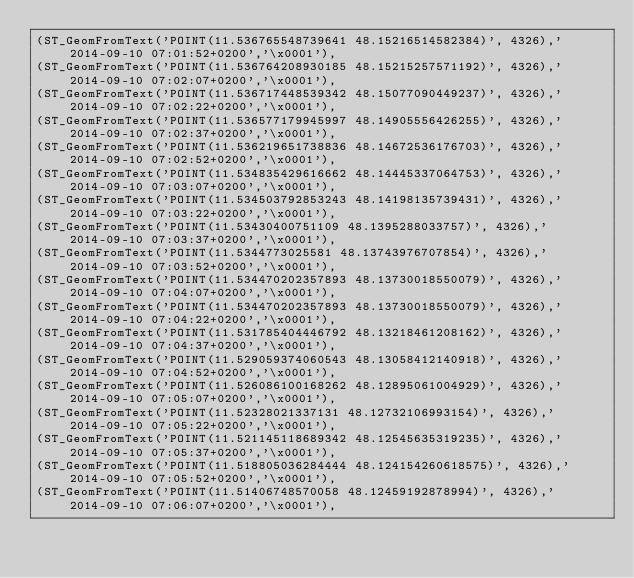<code> <loc_0><loc_0><loc_500><loc_500><_SQL_>(ST_GeomFromText('POINT(11.536765548739641 48.15216514582384)', 4326),'2014-09-10 07:01:52+0200','\x0001'),
(ST_GeomFromText('POINT(11.536764208930185 48.15215257571192)', 4326),'2014-09-10 07:02:07+0200','\x0001'),
(ST_GeomFromText('POINT(11.536717448539342 48.15077090449237)', 4326),'2014-09-10 07:02:22+0200','\x0001'),
(ST_GeomFromText('POINT(11.536577179945997 48.14905556426255)', 4326),'2014-09-10 07:02:37+0200','\x0001'),
(ST_GeomFromText('POINT(11.536219651738836 48.14672536176703)', 4326),'2014-09-10 07:02:52+0200','\x0001'),
(ST_GeomFromText('POINT(11.534835429616662 48.14445337064753)', 4326),'2014-09-10 07:03:07+0200','\x0001'),
(ST_GeomFromText('POINT(11.534503792853243 48.14198135739431)', 4326),'2014-09-10 07:03:22+0200','\x0001'),
(ST_GeomFromText('POINT(11.53430400751109 48.1395288033757)', 4326),'2014-09-10 07:03:37+0200','\x0001'),
(ST_GeomFromText('POINT(11.5344773025581 48.13743976707854)', 4326),'2014-09-10 07:03:52+0200','\x0001'),
(ST_GeomFromText('POINT(11.534470202357893 48.13730018550079)', 4326),'2014-09-10 07:04:07+0200','\x0001'),
(ST_GeomFromText('POINT(11.534470202357893 48.13730018550079)', 4326),'2014-09-10 07:04:22+0200','\x0001'),
(ST_GeomFromText('POINT(11.531785404446792 48.13218461208162)', 4326),'2014-09-10 07:04:37+0200','\x0001'),
(ST_GeomFromText('POINT(11.529059374060543 48.13058412140918)', 4326),'2014-09-10 07:04:52+0200','\x0001'),
(ST_GeomFromText('POINT(11.526086100168262 48.12895061004929)', 4326),'2014-09-10 07:05:07+0200','\x0001'),
(ST_GeomFromText('POINT(11.52328021337131 48.12732106993154)', 4326),'2014-09-10 07:05:22+0200','\x0001'),
(ST_GeomFromText('POINT(11.521145118689342 48.12545635319235)', 4326),'2014-09-10 07:05:37+0200','\x0001'),
(ST_GeomFromText('POINT(11.518805036284444 48.124154260618575)', 4326),'2014-09-10 07:05:52+0200','\x0001'),
(ST_GeomFromText('POINT(11.51406748570058 48.12459192878994)', 4326),'2014-09-10 07:06:07+0200','\x0001'),</code> 